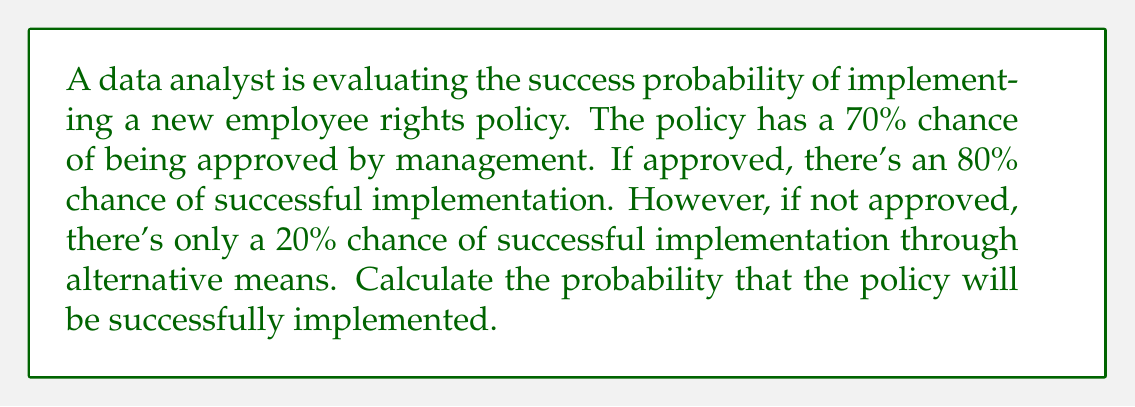Teach me how to tackle this problem. To solve this problem, we'll use the law of total probability and conditional probability.

Let's define our events:
A: Policy is approved
B: Policy is successfully implemented

We're given:
P(A) = 0.70 (70% chance of approval)
P(B|A) = 0.80 (80% chance of successful implementation if approved)
P(B|not A) = 0.20 (20% chance of successful implementation if not approved)

Using the law of total probability:

$$ P(B) = P(B|A) \cdot P(A) + P(B|\text{not }A) \cdot P(\text{not }A) $$

We know P(A) = 0.70, so P(not A) = 1 - P(A) = 0.30

Substituting the values:

$$ P(B) = 0.80 \cdot 0.70 + 0.20 \cdot 0.30 $$

$$ P(B) = 0.56 + 0.06 $$

$$ P(B) = 0.62 $$

Therefore, the probability that the policy will be successfully implemented is 0.62 or 62%.
Answer: The probability of successful policy implementation is 0.62 or 62%. 